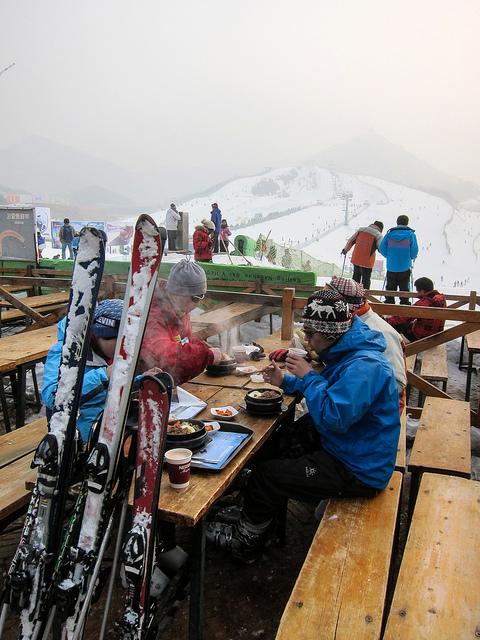Which country could this possibly be?
Write a very short answer. Sweden. What sport are these people taking a break from?
Quick response, please. Skiing. Is everybody wearing a hat?
Concise answer only. No. What are they sitting on?
Give a very brief answer. Benches. 